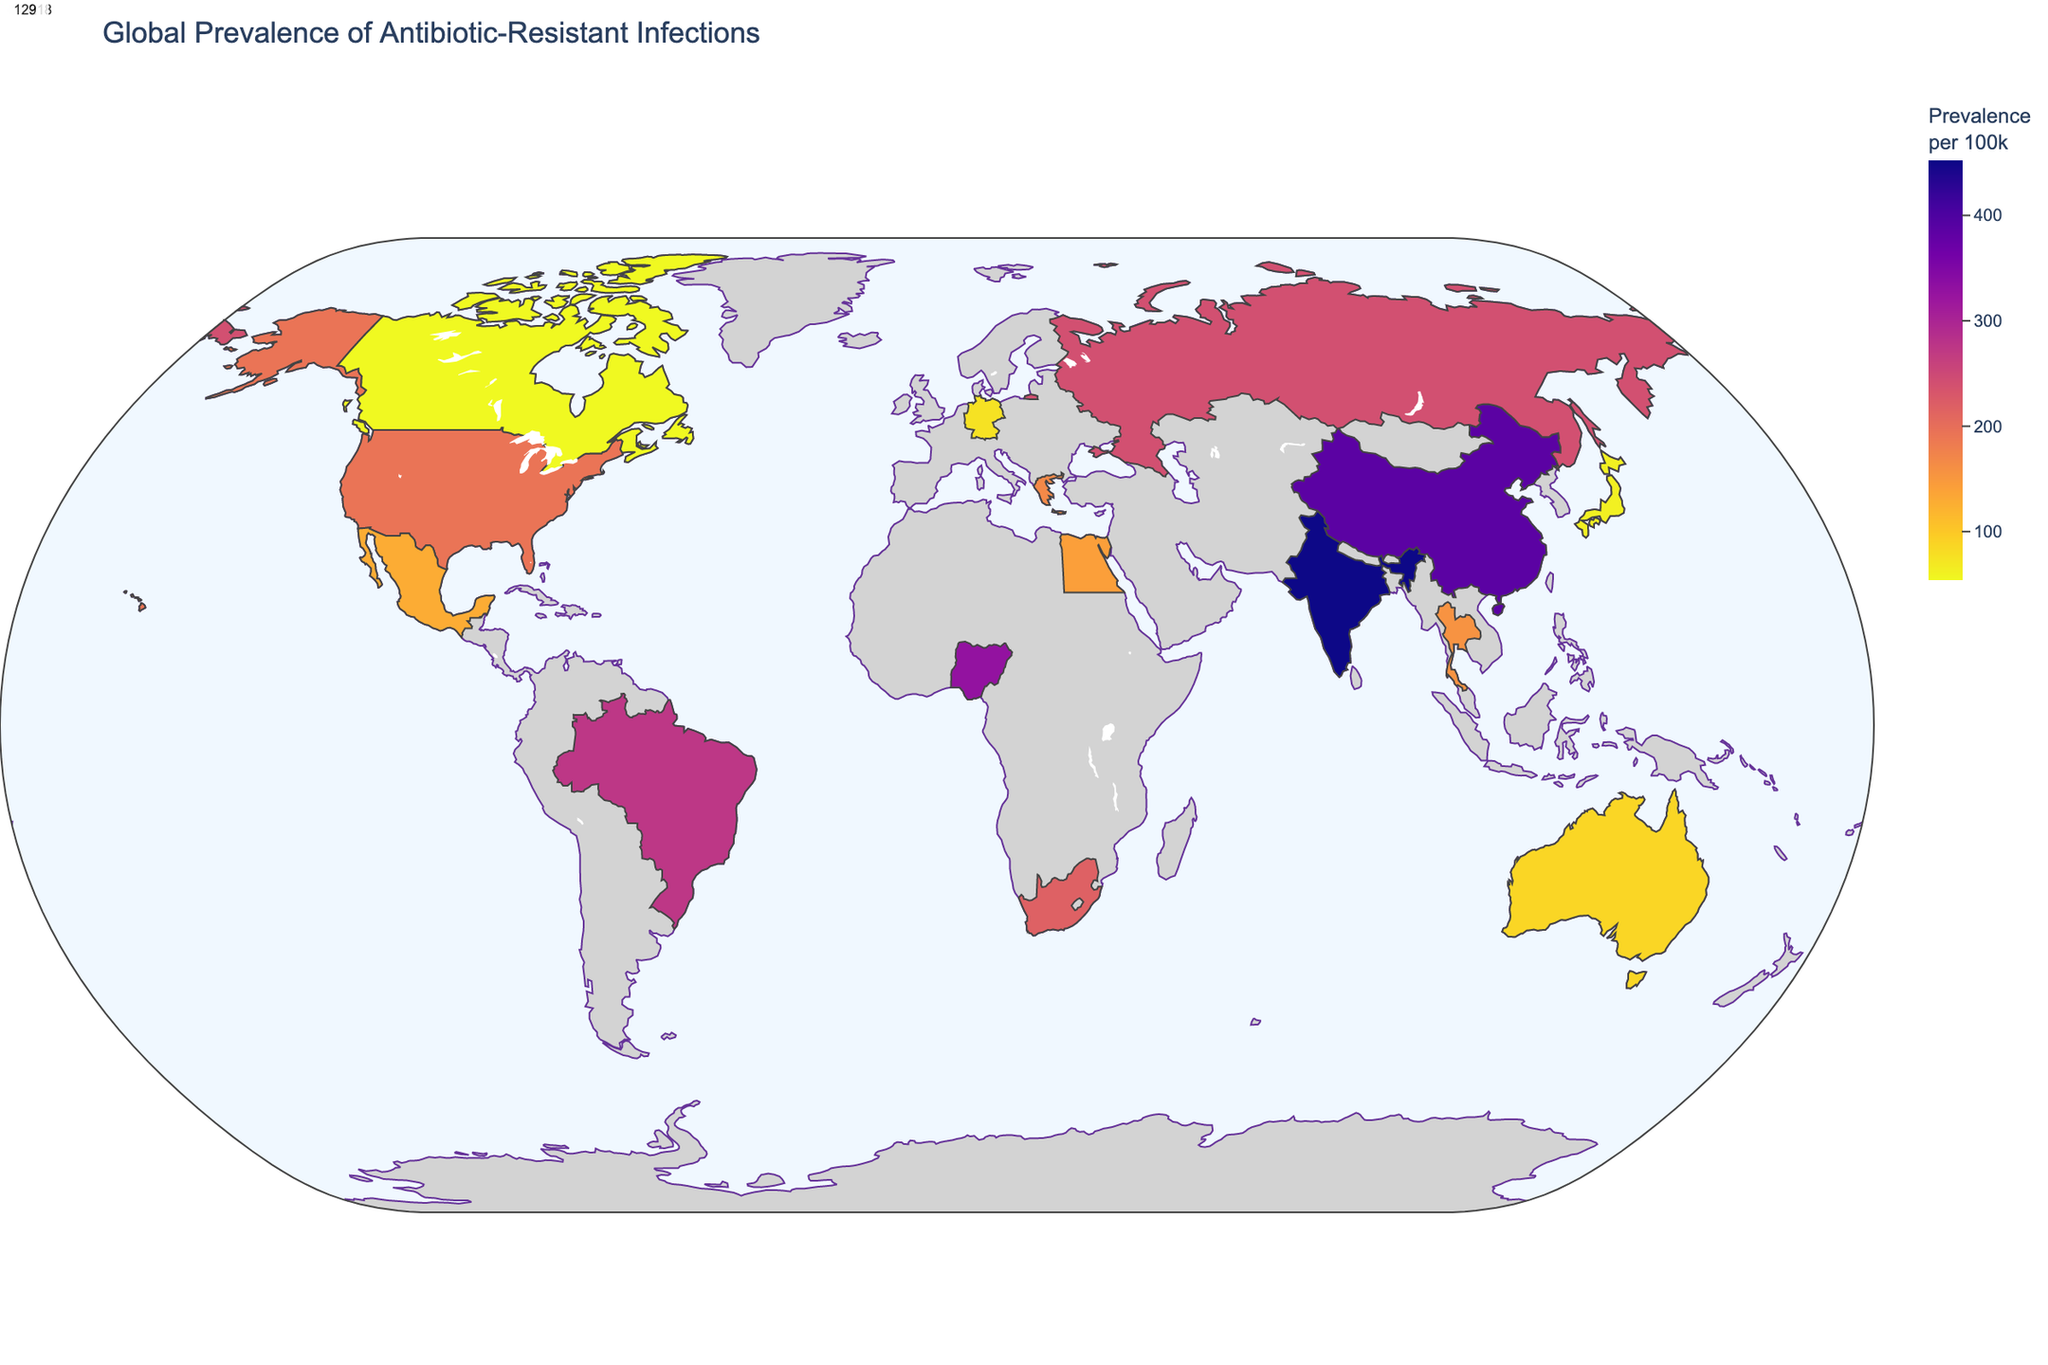How many countries are included in the global prevalence of antibiotic-resistant infections? By counting the number of individual countries represented in the plot, which corresponds to the number of distinct data points, we can determine the total number of countries. There are 14 countries shown in the plot.
Answer: 14 Which country has the highest prevalence of antibiotic-resistant infections? By examining the color intensity and/or referring to the highest numerical prevalence value on the plot's scale, we find that India has the highest prevalence, with 452 antibiotic-resistant infections per 100,000 people.
Answer: India What is the average prevalence of antibiotic-resistant infections in North America? North America includes the United States, Canada, and Mexico. Adding their prevalence rates (193 + 54 + 129) and dividing by the number of countries (3), we get (193 + 54 + 129) / 3 = 376 / 3, which equals approximately 125.33.
Answer: 125.33 Which region has the widest range of antibiotic-resistant infection prevalence rates? By comparing the highest and lowest prevalence rates within each region, we find the range for each one. South Asia has one country with 452 (India) and East Asia has two countries with 387 (China) and 62 (Japan), for example. This shows that East Asia has the widest range, 387 - 62 = 325.
Answer: East Asia Is the prevalence of antibiotic-resistant infections generally higher in Asia compared to the rest of the world based on this plot? By looking at the countries included from Asia (India, China, Japan, Thailand) and comparing their prevalence rates with those from other continents, we can see higher values in Asian countries like India (452) and China (387) compared to lower values in countries outside Asia like Germany (76) and Australia (87). This indicates a generally higher prevalence in Asia.
Answer: Yes Which country has the lowest prevalence among all included? By examining the plot for the country with the lowest color intensity and the lowest numerical value, we note that Canada has the lowest prevalence at 54 per 100,000 people.
Answer: Canada What is the difference in prevalence between the country with the highest rate and the country with the lowest rate? To find the difference between the highest and the lowest prevalence rates, we subtract Canada's prevalence from India's prevalence: 452 - 54 = 398.
Answer: 398 How does the prevalence in Southern Europe (168) compare with that in Northern Europe (76)? By comparing the values directly, we see that the prevalence in Southern Europe (Greece) is higher than in Western Europe (Germany) by 168 - 76 = 92.
Answer: Higher Identify one pathogen that is associated with high levels of antibiotic-resistant infections in both Africa and Asia. By referring to reported pathogens in countries within Africa and Asia, we see that Staphylococcus aureus (Nigeria) and Extensively drug-resistant tuberculosis (South Africa) are major contributors in Africa. In Asia, Escherichia coli (India) and Klebsiella pneumoniae (China) are significant pathogens. No single pathogen is shared, so we identify significant ones for regions.
Answer: No single pathogen What does the color intensity on the map represent? The intensity of the color on the map corresponds to the prevalence of antibiotic-resistant infections per 100,000 people. Darker colors indicate higher prevalence rates.
Answer: Prevalence per 100k 